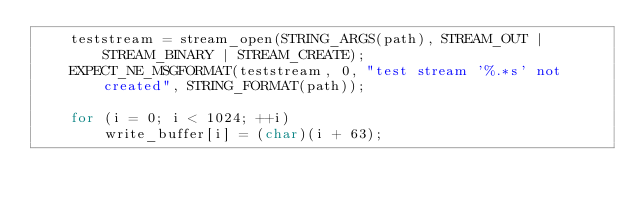<code> <loc_0><loc_0><loc_500><loc_500><_C_>	teststream = stream_open(STRING_ARGS(path), STREAM_OUT | STREAM_BINARY | STREAM_CREATE);
	EXPECT_NE_MSGFORMAT(teststream, 0, "test stream '%.*s' not created", STRING_FORMAT(path));

	for (i = 0; i < 1024; ++i)
		write_buffer[i] = (char)(i + 63);
</code> 